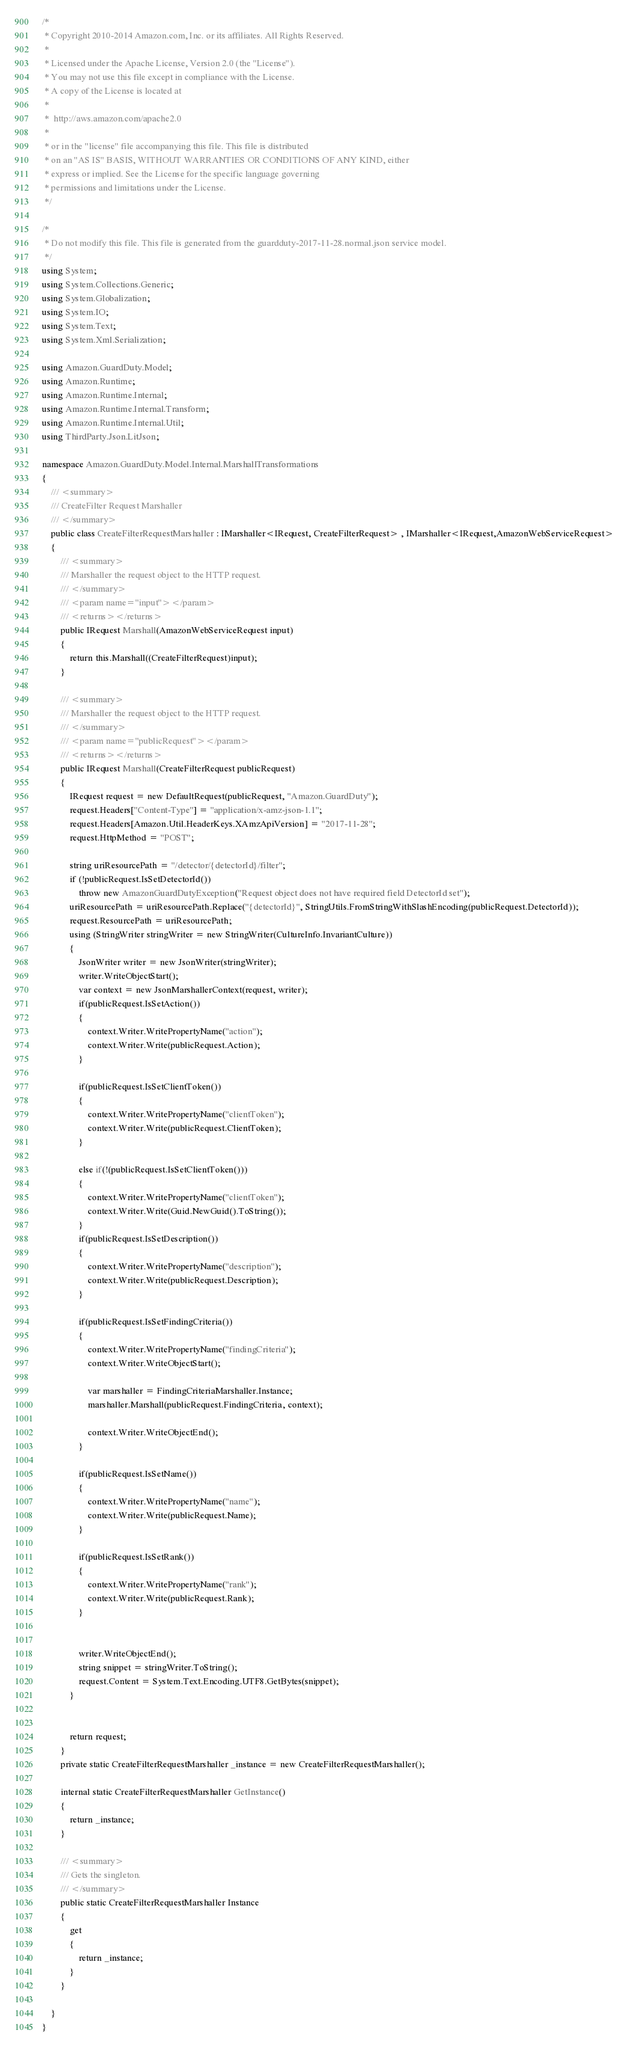Convert code to text. <code><loc_0><loc_0><loc_500><loc_500><_C#_>/*
 * Copyright 2010-2014 Amazon.com, Inc. or its affiliates. All Rights Reserved.
 * 
 * Licensed under the Apache License, Version 2.0 (the "License").
 * You may not use this file except in compliance with the License.
 * A copy of the License is located at
 * 
 *  http://aws.amazon.com/apache2.0
 * 
 * or in the "license" file accompanying this file. This file is distributed
 * on an "AS IS" BASIS, WITHOUT WARRANTIES OR CONDITIONS OF ANY KIND, either
 * express or implied. See the License for the specific language governing
 * permissions and limitations under the License.
 */

/*
 * Do not modify this file. This file is generated from the guardduty-2017-11-28.normal.json service model.
 */
using System;
using System.Collections.Generic;
using System.Globalization;
using System.IO;
using System.Text;
using System.Xml.Serialization;

using Amazon.GuardDuty.Model;
using Amazon.Runtime;
using Amazon.Runtime.Internal;
using Amazon.Runtime.Internal.Transform;
using Amazon.Runtime.Internal.Util;
using ThirdParty.Json.LitJson;

namespace Amazon.GuardDuty.Model.Internal.MarshallTransformations
{
    /// <summary>
    /// CreateFilter Request Marshaller
    /// </summary>       
    public class CreateFilterRequestMarshaller : IMarshaller<IRequest, CreateFilterRequest> , IMarshaller<IRequest,AmazonWebServiceRequest>
    {
        /// <summary>
        /// Marshaller the request object to the HTTP request.
        /// </summary>  
        /// <param name="input"></param>
        /// <returns></returns>
        public IRequest Marshall(AmazonWebServiceRequest input)
        {
            return this.Marshall((CreateFilterRequest)input);
        }

        /// <summary>
        /// Marshaller the request object to the HTTP request.
        /// </summary>  
        /// <param name="publicRequest"></param>
        /// <returns></returns>
        public IRequest Marshall(CreateFilterRequest publicRequest)
        {
            IRequest request = new DefaultRequest(publicRequest, "Amazon.GuardDuty");
            request.Headers["Content-Type"] = "application/x-amz-json-1.1";
            request.Headers[Amazon.Util.HeaderKeys.XAmzApiVersion] = "2017-11-28";            
            request.HttpMethod = "POST";

            string uriResourcePath = "/detector/{detectorId}/filter";
            if (!publicRequest.IsSetDetectorId())
                throw new AmazonGuardDutyException("Request object does not have required field DetectorId set");
            uriResourcePath = uriResourcePath.Replace("{detectorId}", StringUtils.FromStringWithSlashEncoding(publicRequest.DetectorId));
            request.ResourcePath = uriResourcePath;
            using (StringWriter stringWriter = new StringWriter(CultureInfo.InvariantCulture))
            {
                JsonWriter writer = new JsonWriter(stringWriter);
                writer.WriteObjectStart();
                var context = new JsonMarshallerContext(request, writer);
                if(publicRequest.IsSetAction())
                {
                    context.Writer.WritePropertyName("action");
                    context.Writer.Write(publicRequest.Action);
                }

                if(publicRequest.IsSetClientToken())
                {
                    context.Writer.WritePropertyName("clientToken");
                    context.Writer.Write(publicRequest.ClientToken);
                }

                else if(!(publicRequest.IsSetClientToken()))
                {
                    context.Writer.WritePropertyName("clientToken");
                    context.Writer.Write(Guid.NewGuid().ToString());                                                
                }
                if(publicRequest.IsSetDescription())
                {
                    context.Writer.WritePropertyName("description");
                    context.Writer.Write(publicRequest.Description);
                }

                if(publicRequest.IsSetFindingCriteria())
                {
                    context.Writer.WritePropertyName("findingCriteria");
                    context.Writer.WriteObjectStart();

                    var marshaller = FindingCriteriaMarshaller.Instance;
                    marshaller.Marshall(publicRequest.FindingCriteria, context);

                    context.Writer.WriteObjectEnd();
                }

                if(publicRequest.IsSetName())
                {
                    context.Writer.WritePropertyName("name");
                    context.Writer.Write(publicRequest.Name);
                }

                if(publicRequest.IsSetRank())
                {
                    context.Writer.WritePropertyName("rank");
                    context.Writer.Write(publicRequest.Rank);
                }

        
                writer.WriteObjectEnd();
                string snippet = stringWriter.ToString();
                request.Content = System.Text.Encoding.UTF8.GetBytes(snippet);
            }


            return request;
        }
        private static CreateFilterRequestMarshaller _instance = new CreateFilterRequestMarshaller();        

        internal static CreateFilterRequestMarshaller GetInstance()
        {
            return _instance;
        }

        /// <summary>
        /// Gets the singleton.
        /// </summary>  
        public static CreateFilterRequestMarshaller Instance
        {
            get
            {
                return _instance;
            }
        }

    }
}</code> 